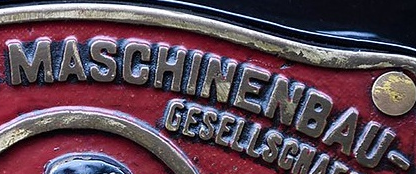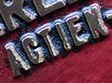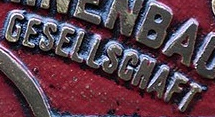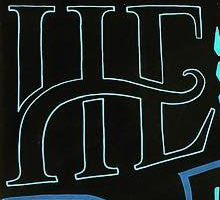What text appears in these images from left to right, separated by a semicolon? MASCHINENBAU; AGTIEN; GESELLSGNAFT; HE 